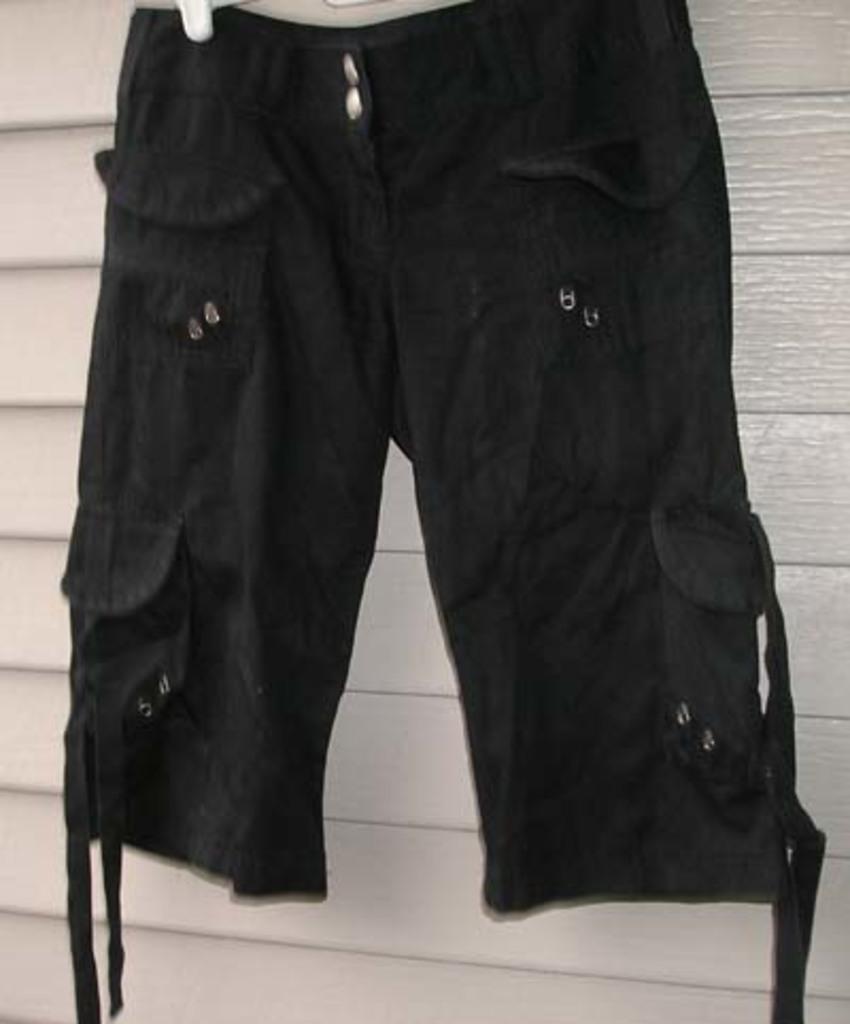How would you summarize this image in a sentence or two? In this picture we can see shorts. 